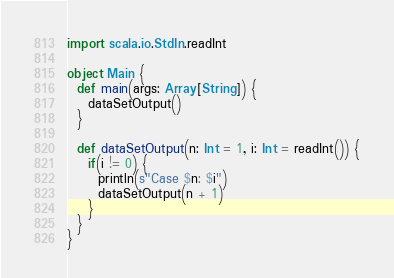<code> <loc_0><loc_0><loc_500><loc_500><_Scala_>import scala.io.StdIn.readInt

object Main {
  def main(args: Array[String]) {
    dataSetOutput()
  }

  def dataSetOutput(n: Int = 1, i: Int = readInt()) {
    if(i != 0) {
      println(s"Case $n: $i")
      dataSetOutput(n + 1)
    }
  }
}</code> 